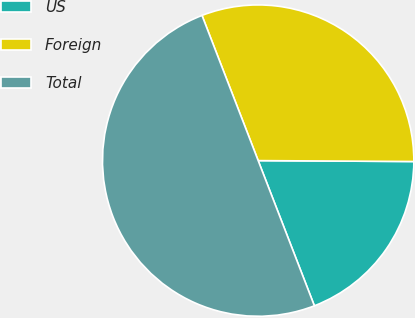Convert chart to OTSL. <chart><loc_0><loc_0><loc_500><loc_500><pie_chart><fcel>US<fcel>Foreign<fcel>Total<nl><fcel>19.03%<fcel>30.97%<fcel>50.0%<nl></chart> 